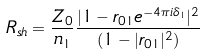Convert formula to latex. <formula><loc_0><loc_0><loc_500><loc_500>R _ { s h } = \frac { Z _ { 0 } } { n _ { 1 } } \frac { | 1 - r _ { 0 1 } e ^ { - 4 \pi i \delta _ { 1 } } | ^ { 2 } } { ( 1 - | r _ { 0 1 } | ^ { 2 } ) }</formula> 